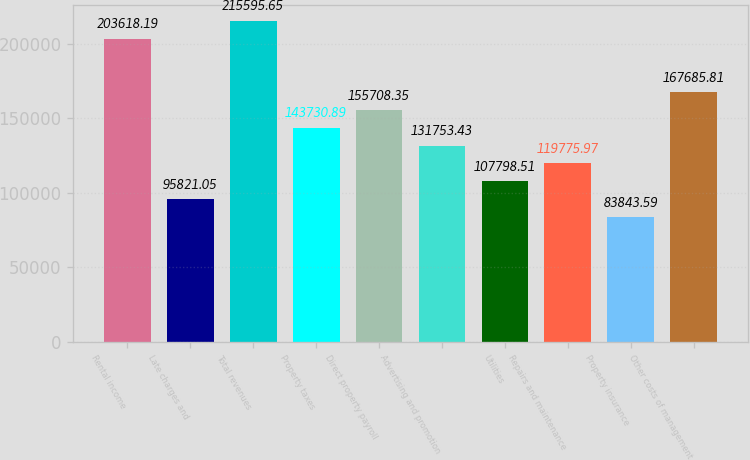Convert chart to OTSL. <chart><loc_0><loc_0><loc_500><loc_500><bar_chart><fcel>Rental income<fcel>Late charges and<fcel>Total revenues<fcel>Property taxes<fcel>Direct property payroll<fcel>Advertising and promotion<fcel>Utilities<fcel>Repairs and maintenance<fcel>Property insurance<fcel>Other costs of management<nl><fcel>203618<fcel>95821.1<fcel>215596<fcel>143731<fcel>155708<fcel>131753<fcel>107799<fcel>119776<fcel>83843.6<fcel>167686<nl></chart> 